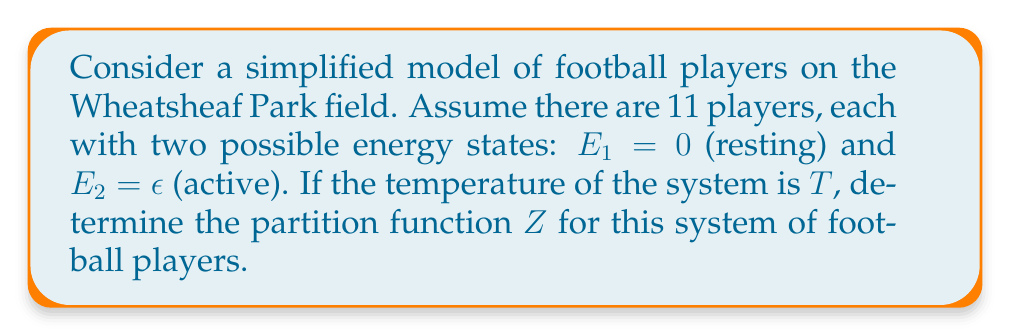Teach me how to tackle this problem. Let's approach this step-by-step:

1) The partition function $Z$ for a system is given by:

   $$Z = \sum_i e^{-\beta E_i}$$

   where $\beta = \frac{1}{k_B T}$, $k_B$ is Boltzmann's constant, and $T$ is temperature.

2) In our case, each player has two possible states. The partition function for a single player ($z$) is:

   $$z = e^{-\beta E_1} + e^{-\beta E_2} = 1 + e^{-\beta \epsilon}$$

3) Since we have 11 independent players, and each can be in either state, the total partition function is the product of the individual partition functions:

   $$Z = z^{11} = (1 + e^{-\beta \epsilon})^{11}$$

4) Expanding this using the binomial theorem:

   $$Z = \sum_{k=0}^{11} \binom{11}{k} e^{-k\beta \epsilon}$$

5) This can be interpreted as the sum over all possible configurations where $k$ players are in the active state and $(11-k)$ players are in the resting state.
Answer: $Z = (1 + e^{-\beta \epsilon})^{11} = \sum_{k=0}^{11} \binom{11}{k} e^{-k\beta \epsilon}$ 